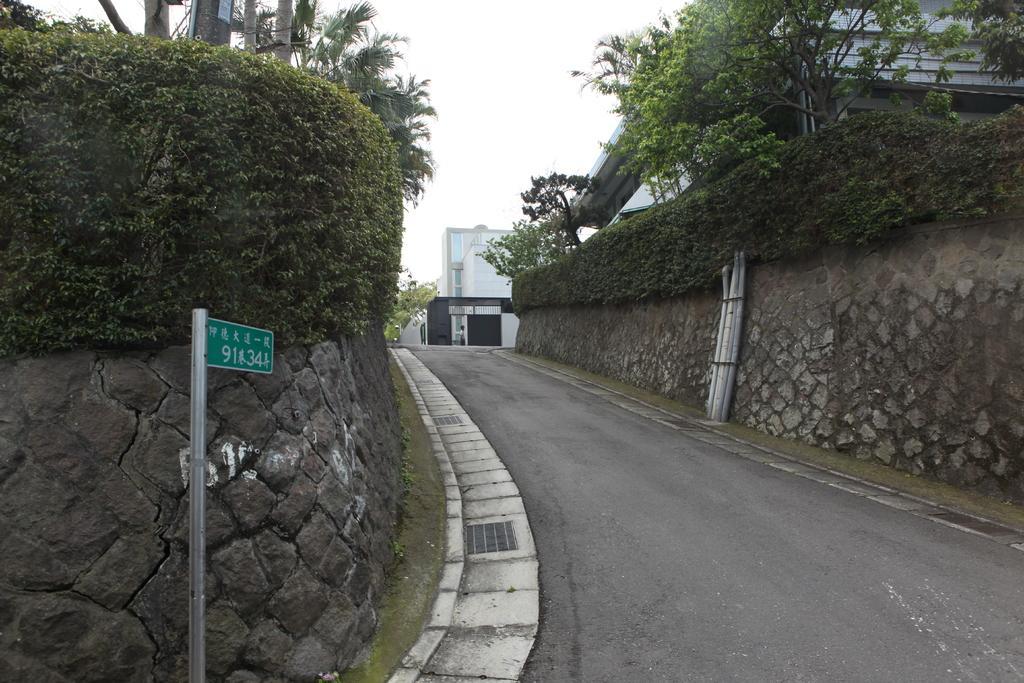Can you describe this image briefly? In the picture I can see the road. I can see the rock wall and bushes on the left side and the right side of the road. There is a board pole on the left side of the image. In the background, I can see the building and a metal gate. I can see the trees on the left side and the right side as well. 